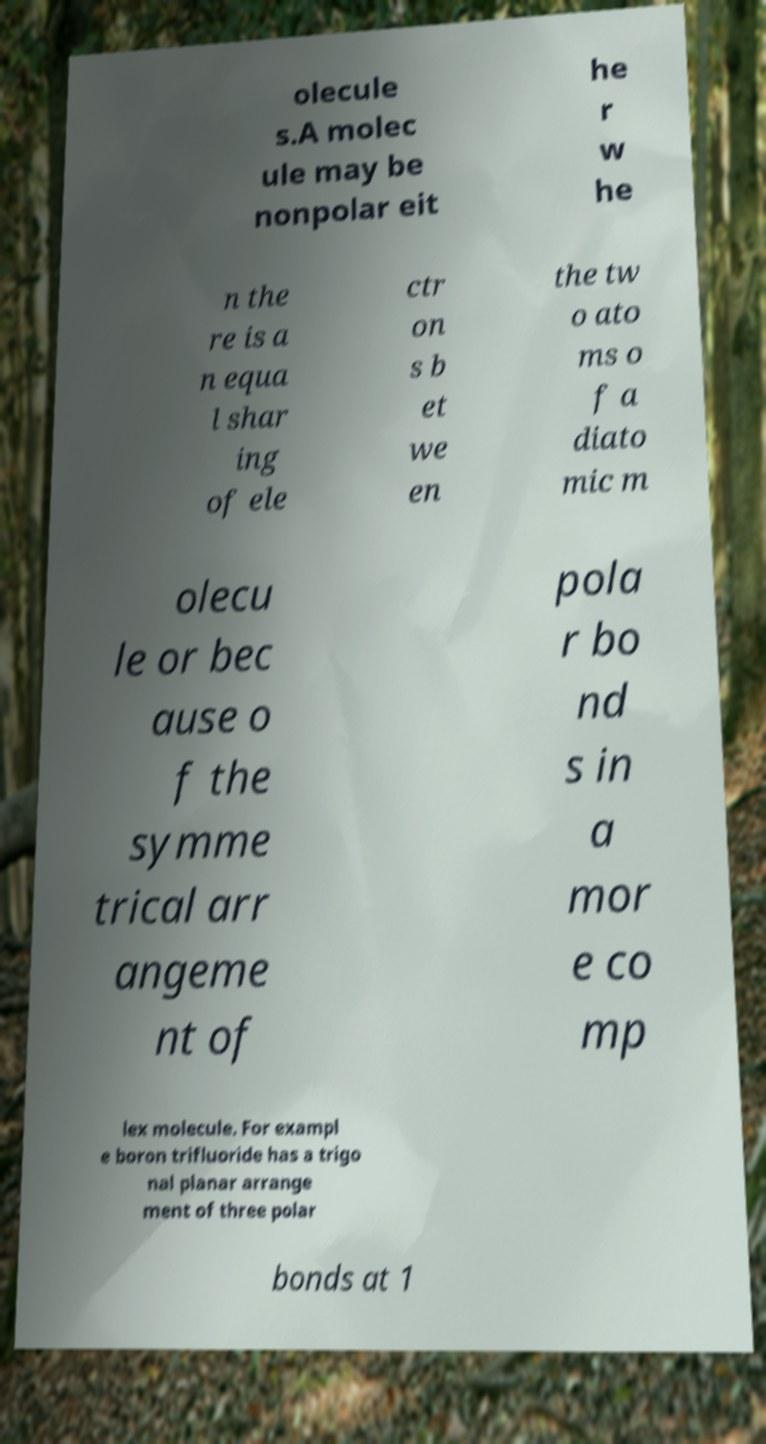What messages or text are displayed in this image? I need them in a readable, typed format. olecule s.A molec ule may be nonpolar eit he r w he n the re is a n equa l shar ing of ele ctr on s b et we en the tw o ato ms o f a diato mic m olecu le or bec ause o f the symme trical arr angeme nt of pola r bo nd s in a mor e co mp lex molecule. For exampl e boron trifluoride has a trigo nal planar arrange ment of three polar bonds at 1 